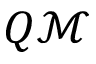Convert formula to latex. <formula><loc_0><loc_0><loc_500><loc_500>Q \mathcal { M }</formula> 